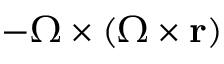<formula> <loc_0><loc_0><loc_500><loc_500>- { \Omega } \times ( { \Omega } \times r )</formula> 